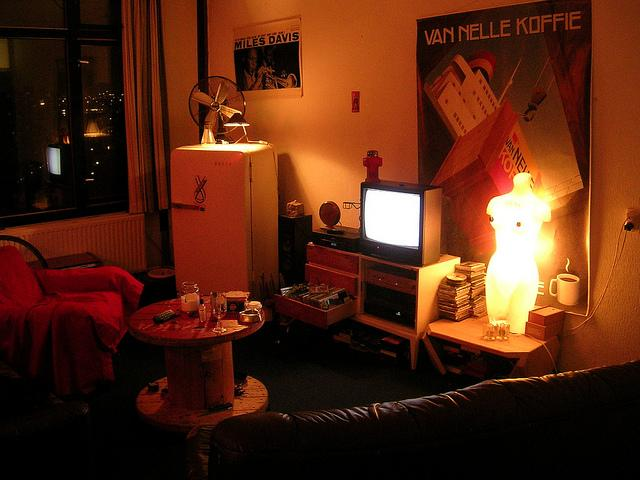The last word on the poster on the right is most likely pronounced similarly to what? coffee 